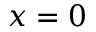<formula> <loc_0><loc_0><loc_500><loc_500>x = 0</formula> 